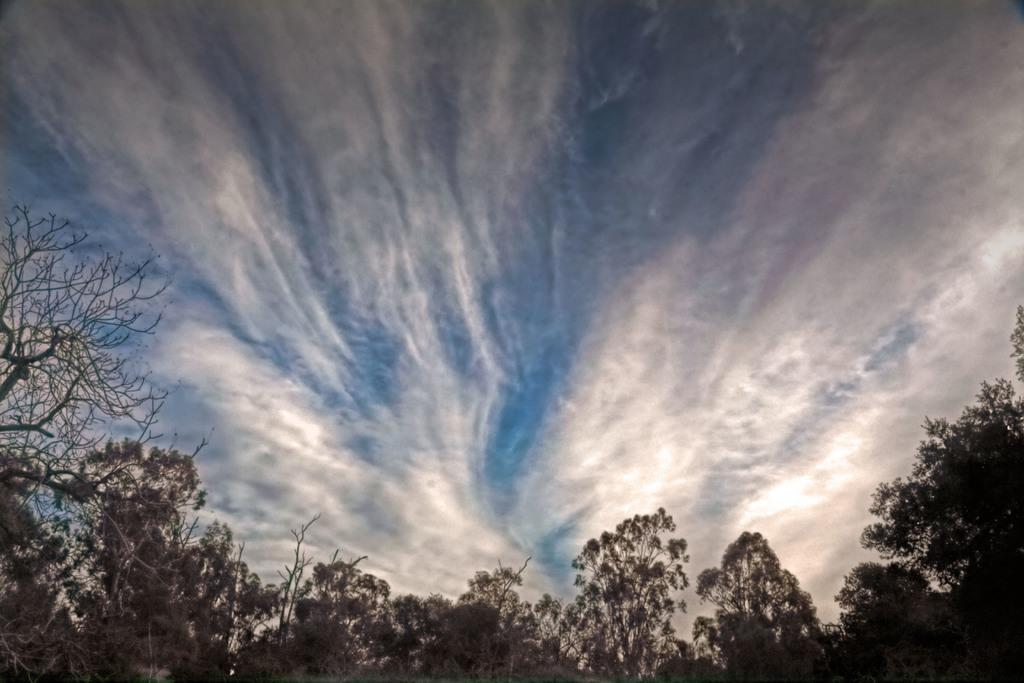What type of vegetation is visible in the foreground area of the image? There are trees in the foreground area of the image. What part of the natural environment is visible in the background area of the image? The sky is visible in the background area of the image. Can you see any necks or owls in the image? There are no necks or owls present in the image; it features trees in the foreground and the sky in the background. Is there any mention of debt in the image? There is no mention of debt in the image. 